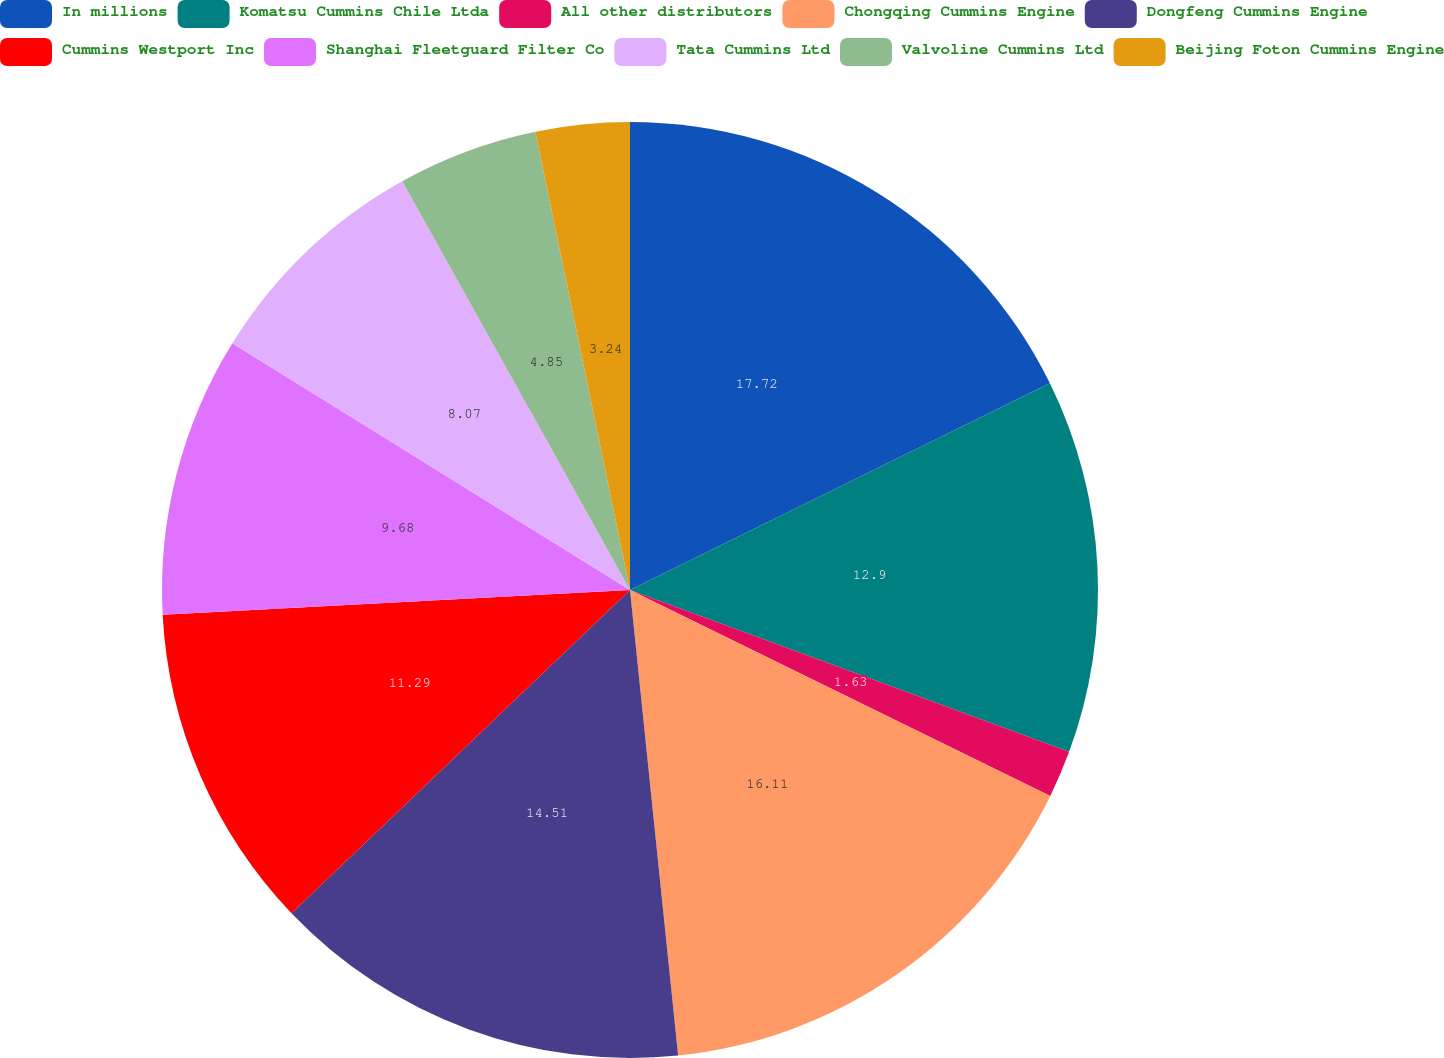Convert chart. <chart><loc_0><loc_0><loc_500><loc_500><pie_chart><fcel>In millions<fcel>Komatsu Cummins Chile Ltda<fcel>All other distributors<fcel>Chongqing Cummins Engine<fcel>Dongfeng Cummins Engine<fcel>Cummins Westport Inc<fcel>Shanghai Fleetguard Filter Co<fcel>Tata Cummins Ltd<fcel>Valvoline Cummins Ltd<fcel>Beijing Foton Cummins Engine<nl><fcel>17.72%<fcel>12.9%<fcel>1.63%<fcel>16.11%<fcel>14.51%<fcel>11.29%<fcel>9.68%<fcel>8.07%<fcel>4.85%<fcel>3.24%<nl></chart> 